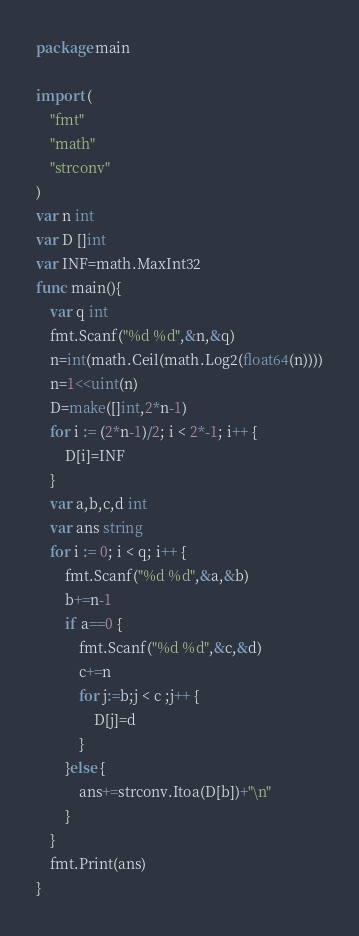<code> <loc_0><loc_0><loc_500><loc_500><_Go_>package main

import (
	"fmt"
	"math"
	"strconv"
)
var n int
var D []int
var INF=math.MaxInt32
func main(){
	var q int
	fmt.Scanf("%d %d",&n,&q)
	n=int(math.Ceil(math.Log2(float64(n))))
	n=1<<uint(n)
	D=make([]int,2*n-1)
	for i := (2*n-1)/2; i < 2*-1; i++ {
		D[i]=INF
	}
	var a,b,c,d int
	var ans string
	for i := 0; i < q; i++ {
		fmt.Scanf("%d %d",&a,&b)
		b+=n-1
		if a==0 {
			fmt.Scanf("%d %d",&c,&d)
			c+=n
			for j:=b;j < c ;j++ {
				D[j]=d
			}
		}else {
			ans+=strconv.Itoa(D[b])+"\n"
		}
	}
	fmt.Print(ans)
}
</code> 